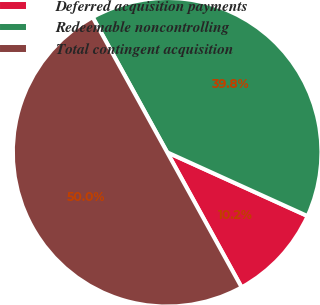Convert chart to OTSL. <chart><loc_0><loc_0><loc_500><loc_500><pie_chart><fcel>Deferred acquisition payments<fcel>Redeemable noncontrolling<fcel>Total contingent acquisition<nl><fcel>10.19%<fcel>39.81%<fcel>50.0%<nl></chart> 